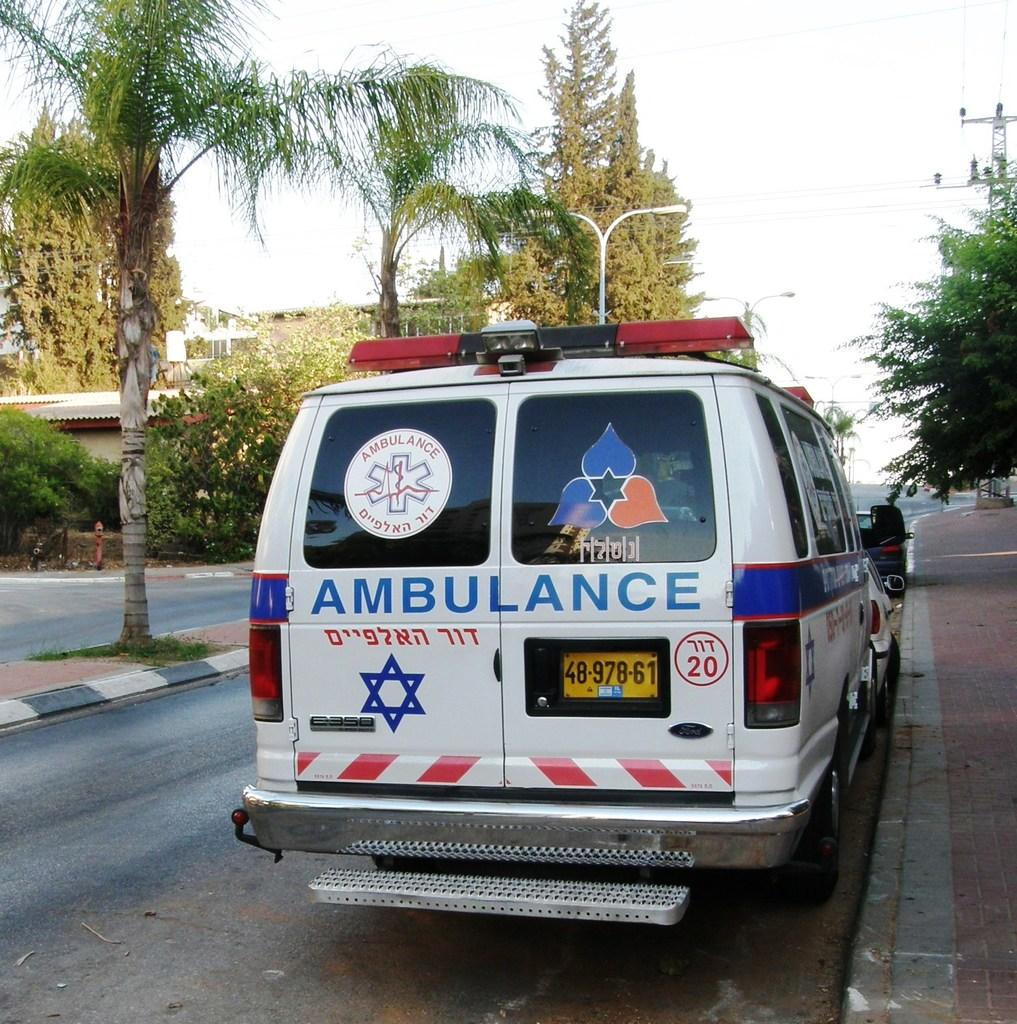<image>
Offer a succinct explanation of the picture presented. an ambulance that is outside among trees during day 